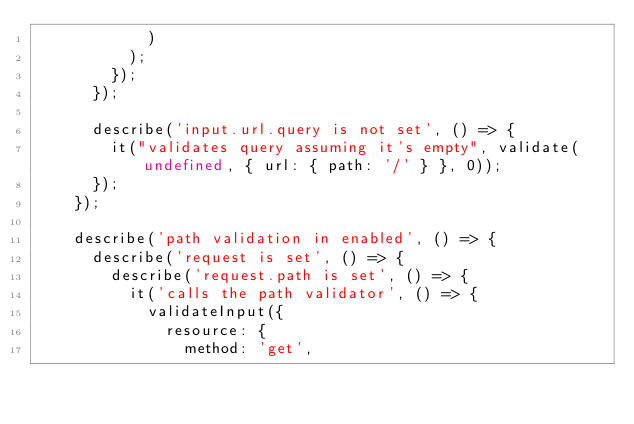<code> <loc_0><loc_0><loc_500><loc_500><_TypeScript_>            )
          );
        });
      });

      describe('input.url.query is not set', () => {
        it("validates query assuming it's empty", validate(undefined, { url: { path: '/' } }, 0));
      });
    });

    describe('path validation in enabled', () => {
      describe('request is set', () => {
        describe('request.path is set', () => {
          it('calls the path validator', () => {
            validateInput({
              resource: {
                method: 'get',</code> 